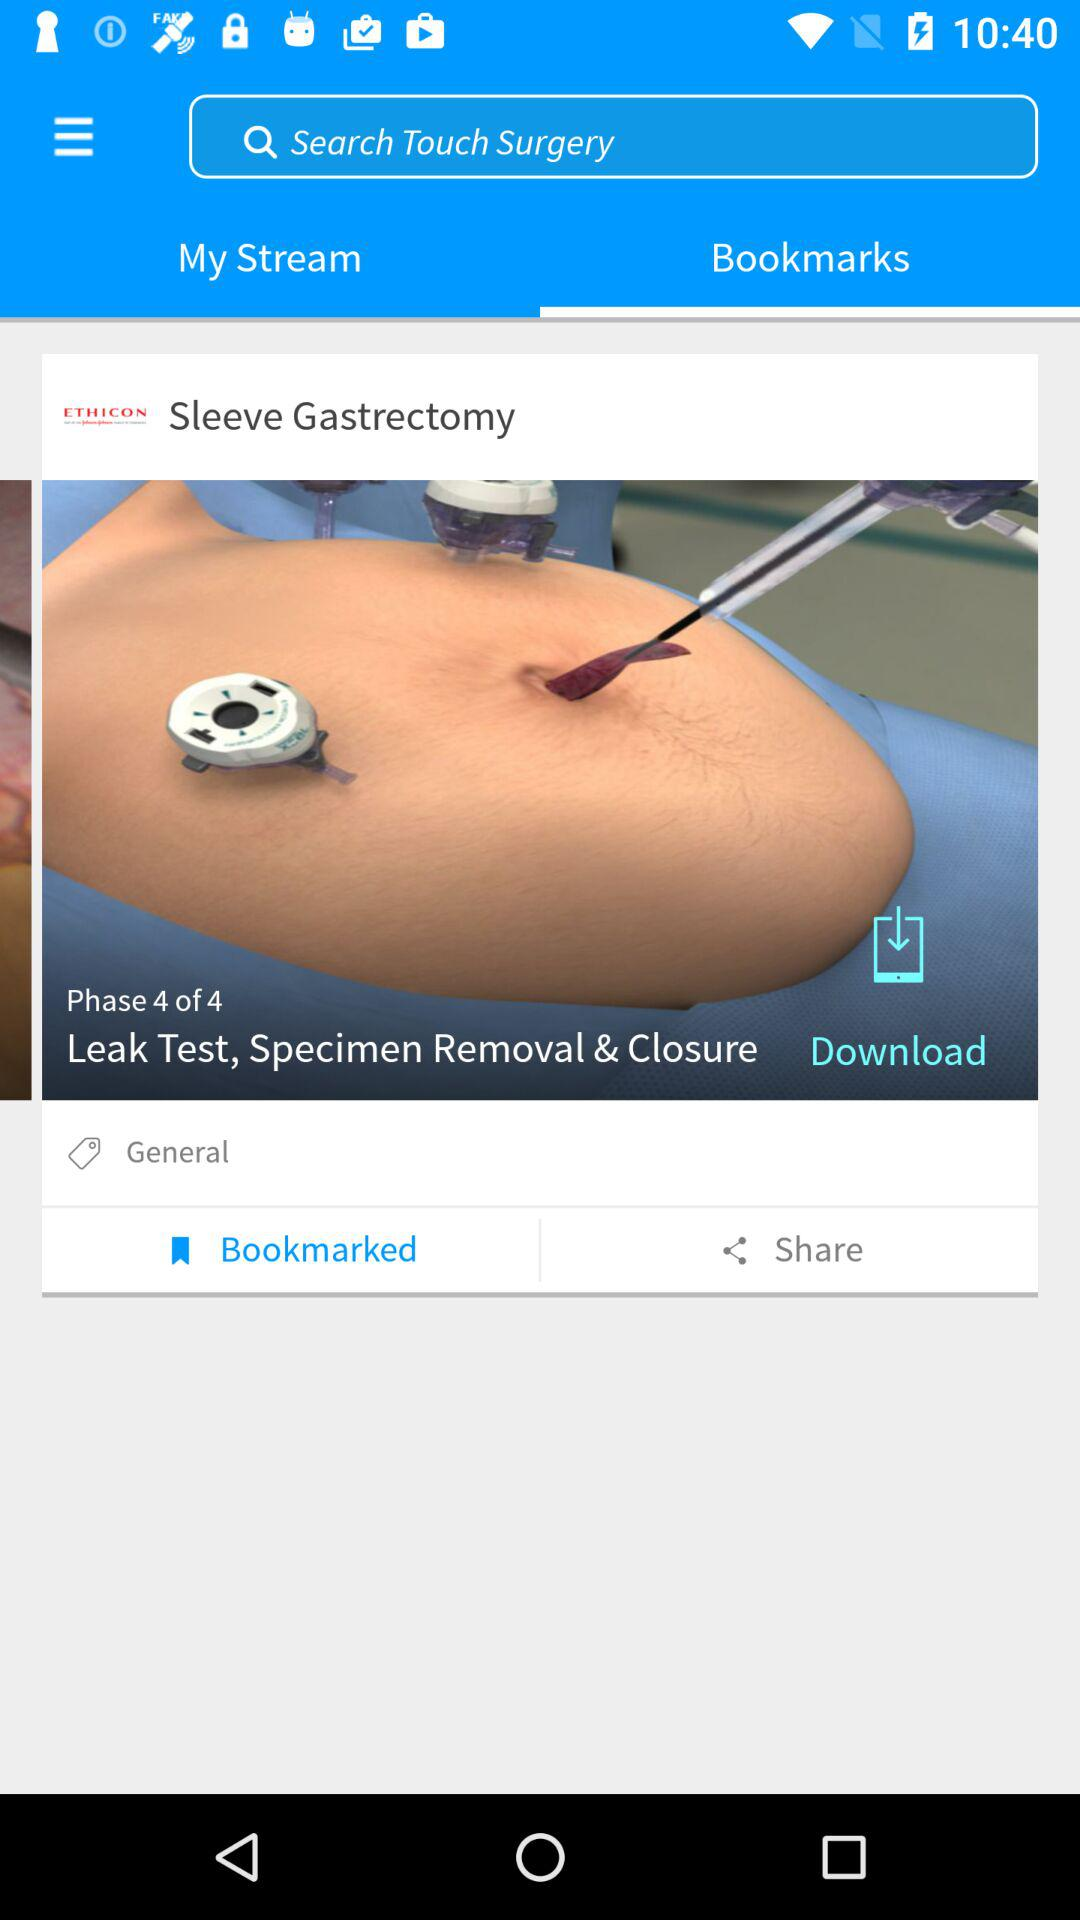What is the selected tab? The selected tab is "Bookmarks". 